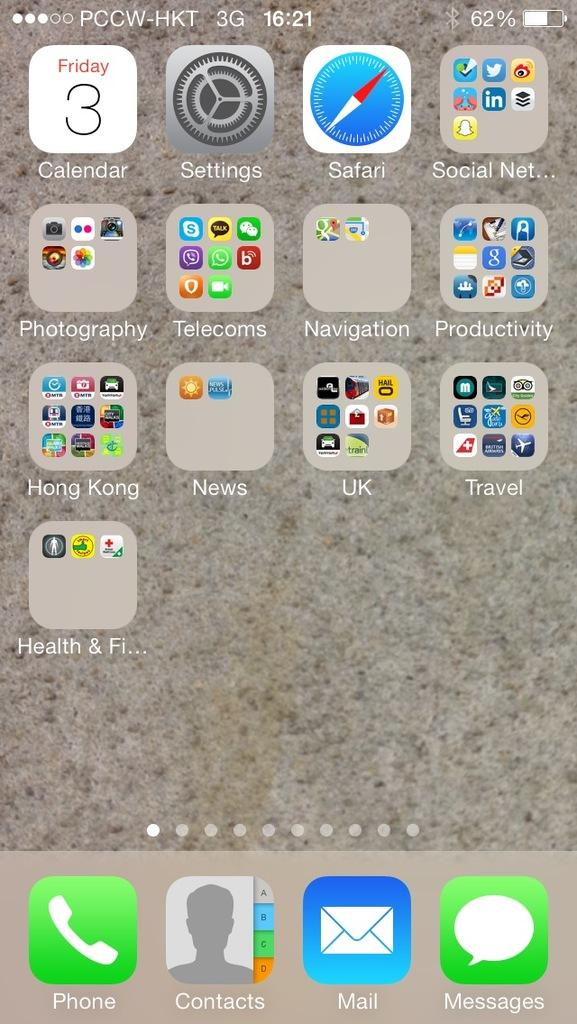Provide a one-sentence caption for the provided image. A screenshot of a phone interface with 3G signal. 